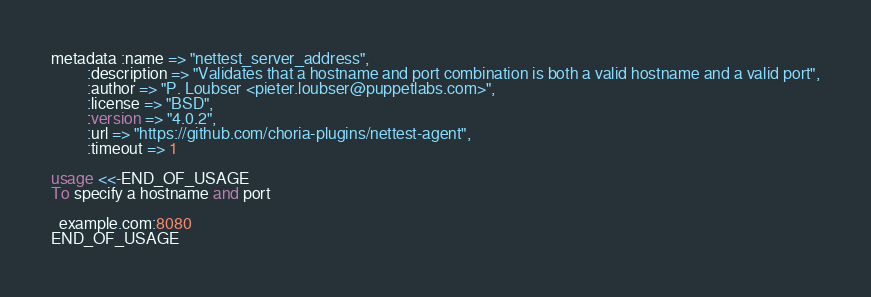<code> <loc_0><loc_0><loc_500><loc_500><_SQL_>metadata :name => "nettest_server_address",
         :description => "Validates that a hostname and port combination is both a valid hostname and a valid port",
         :author => "P. Loubser <pieter.loubser@puppetlabs.com>",
         :license => "BSD",
         :version => "4.0.2",
         :url => "https://github.com/choria-plugins/nettest-agent",
         :timeout => 1

usage <<-END_OF_USAGE
To specify a hostname and port

  example.com:8080
END_OF_USAGE
</code> 